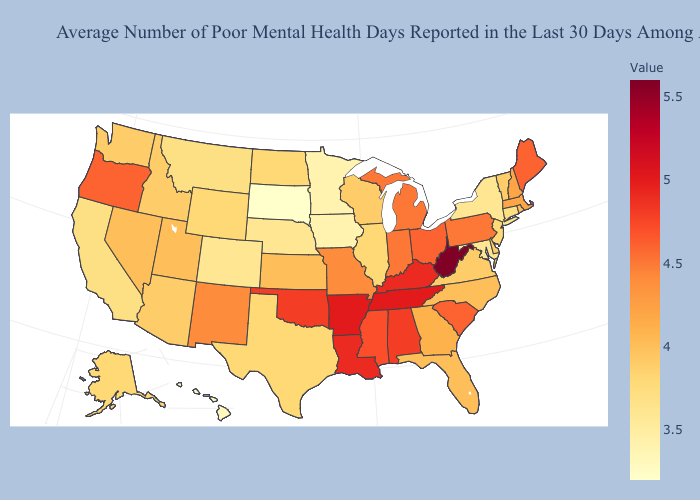Does Hawaii have the lowest value in the West?
Short answer required. Yes. Does Kansas have the lowest value in the MidWest?
Be succinct. No. 